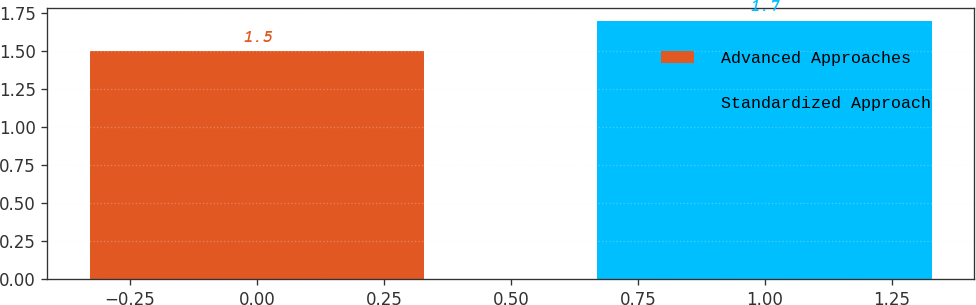Convert chart to OTSL. <chart><loc_0><loc_0><loc_500><loc_500><bar_chart><fcel>Advanced Approaches<fcel>Standardized Approach<nl><fcel>1.5<fcel>1.7<nl></chart> 